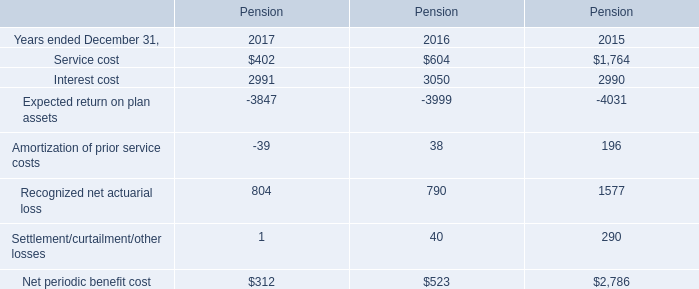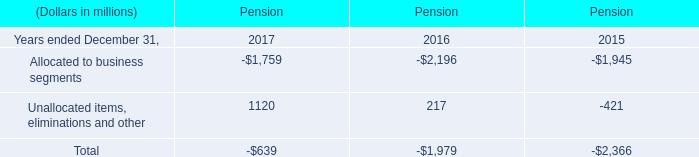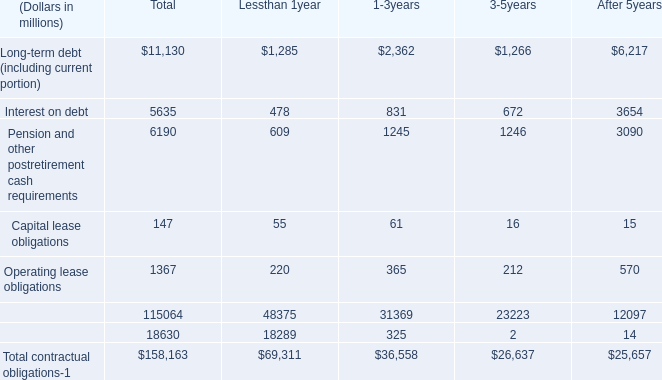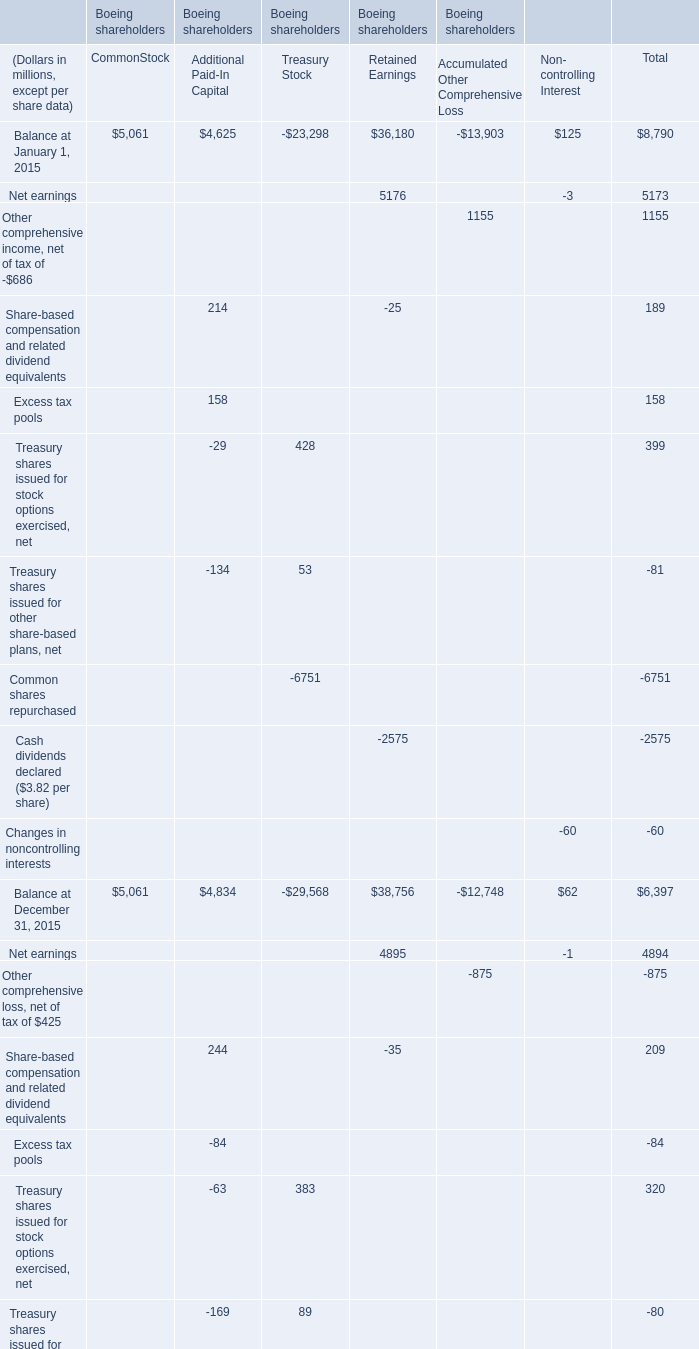What's the sum of Interest cost of Pension 2015, Balance at December 31, 2016 of Boeing shareholders Retained Earnings, and Treasury shares contributed to pension plans of Boeing shareholders Treasury Stock ? 
Computations: ((2990.0 + 40714.0) + 1418.0)
Answer: 45122.0. 